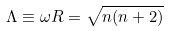<formula> <loc_0><loc_0><loc_500><loc_500>\Lambda \equiv \omega R = \sqrt { n ( n + 2 ) }</formula> 